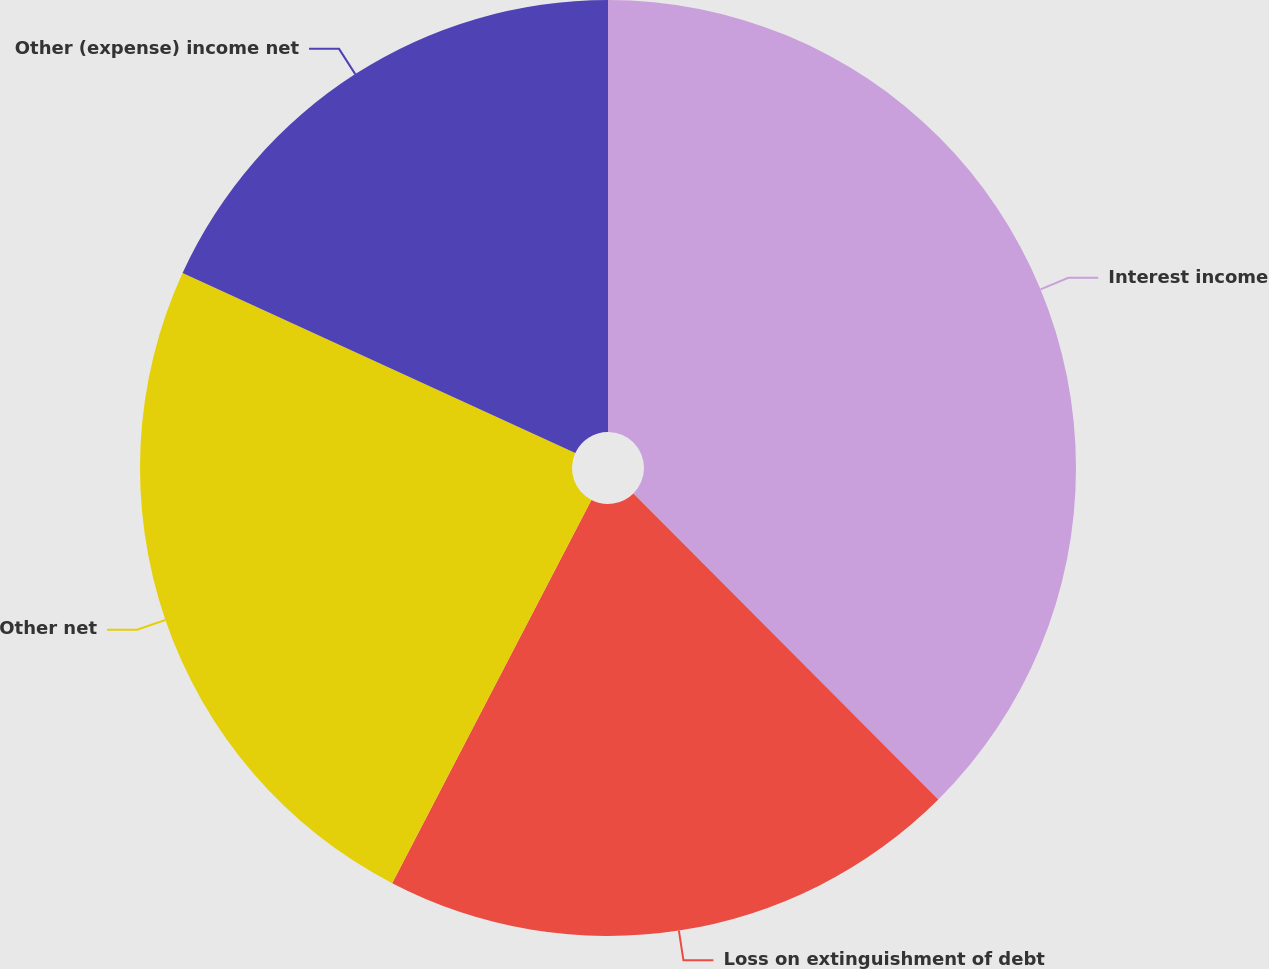Convert chart to OTSL. <chart><loc_0><loc_0><loc_500><loc_500><pie_chart><fcel>Interest income<fcel>Loss on extinguishment of debt<fcel>Other net<fcel>Other (expense) income net<nl><fcel>37.53%<fcel>20.1%<fcel>24.21%<fcel>18.16%<nl></chart> 